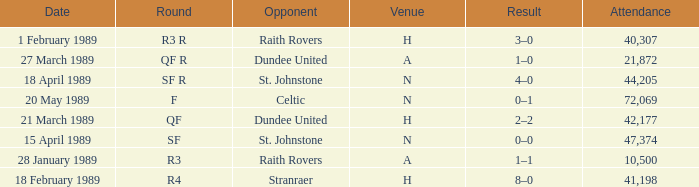When is the round scheduled for in sf? 15 April 1989. 